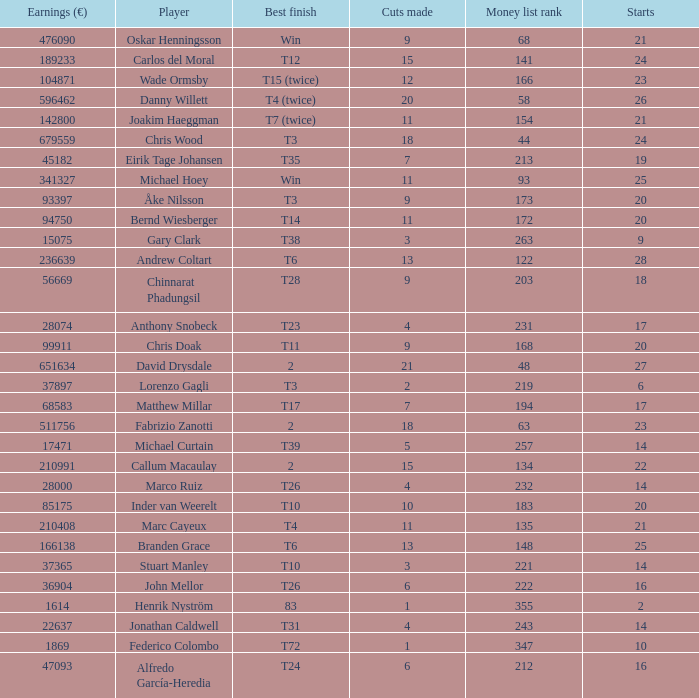How many cuts did Gary Clark make? 3.0. 